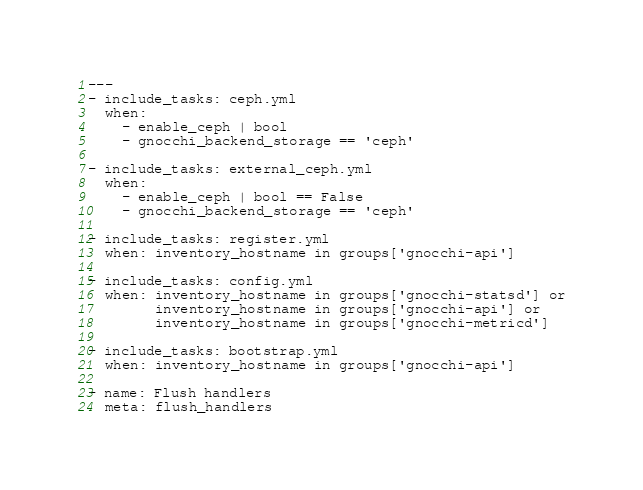Convert code to text. <code><loc_0><loc_0><loc_500><loc_500><_YAML_>---
- include_tasks: ceph.yml
  when:
    - enable_ceph | bool
    - gnocchi_backend_storage == 'ceph'

- include_tasks: external_ceph.yml
  when:
    - enable_ceph | bool == False
    - gnocchi_backend_storage == 'ceph'

- include_tasks: register.yml
  when: inventory_hostname in groups['gnocchi-api']

- include_tasks: config.yml
  when: inventory_hostname in groups['gnocchi-statsd'] or
        inventory_hostname in groups['gnocchi-api'] or
        inventory_hostname in groups['gnocchi-metricd']

- include_tasks: bootstrap.yml
  when: inventory_hostname in groups['gnocchi-api']

- name: Flush handlers
  meta: flush_handlers
</code> 